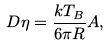<formula> <loc_0><loc_0><loc_500><loc_500>D \eta = \frac { k T _ { B } } { 6 \pi R } A ,</formula> 